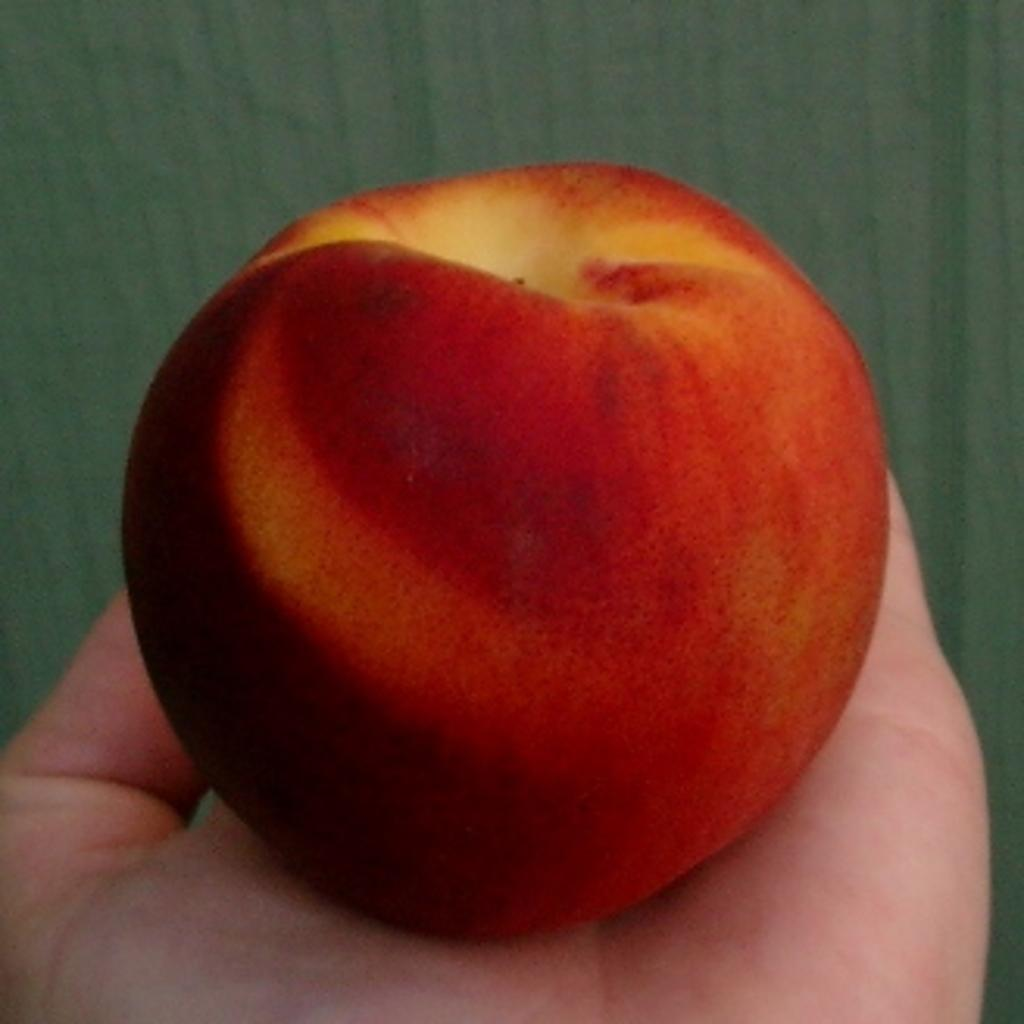What is the main subject of the image? There is a person in the image. What is the person holding in the image? The person is holding an apple. How is the apple being held by the person? The apple is on the person's palm. Can you describe the colors of the apple? The apple has red and pale yellow colors. What type of haircut does the person have in the image? There is no information about the person's haircut in the image. What type of linen is visible in the image? There is no linen present in the image. 